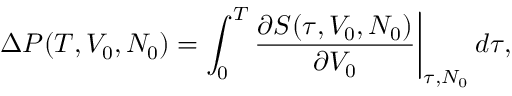Convert formula to latex. <formula><loc_0><loc_0><loc_500><loc_500>\Delta P ( T , V _ { 0 } , N _ { 0 } ) = \int _ { 0 } ^ { T } \frac { \partial S ( \tau , V _ { 0 } , N _ { 0 } ) } { \partial V _ { 0 } } \Big | _ { \tau , N _ { 0 } } \, d \tau ,</formula> 